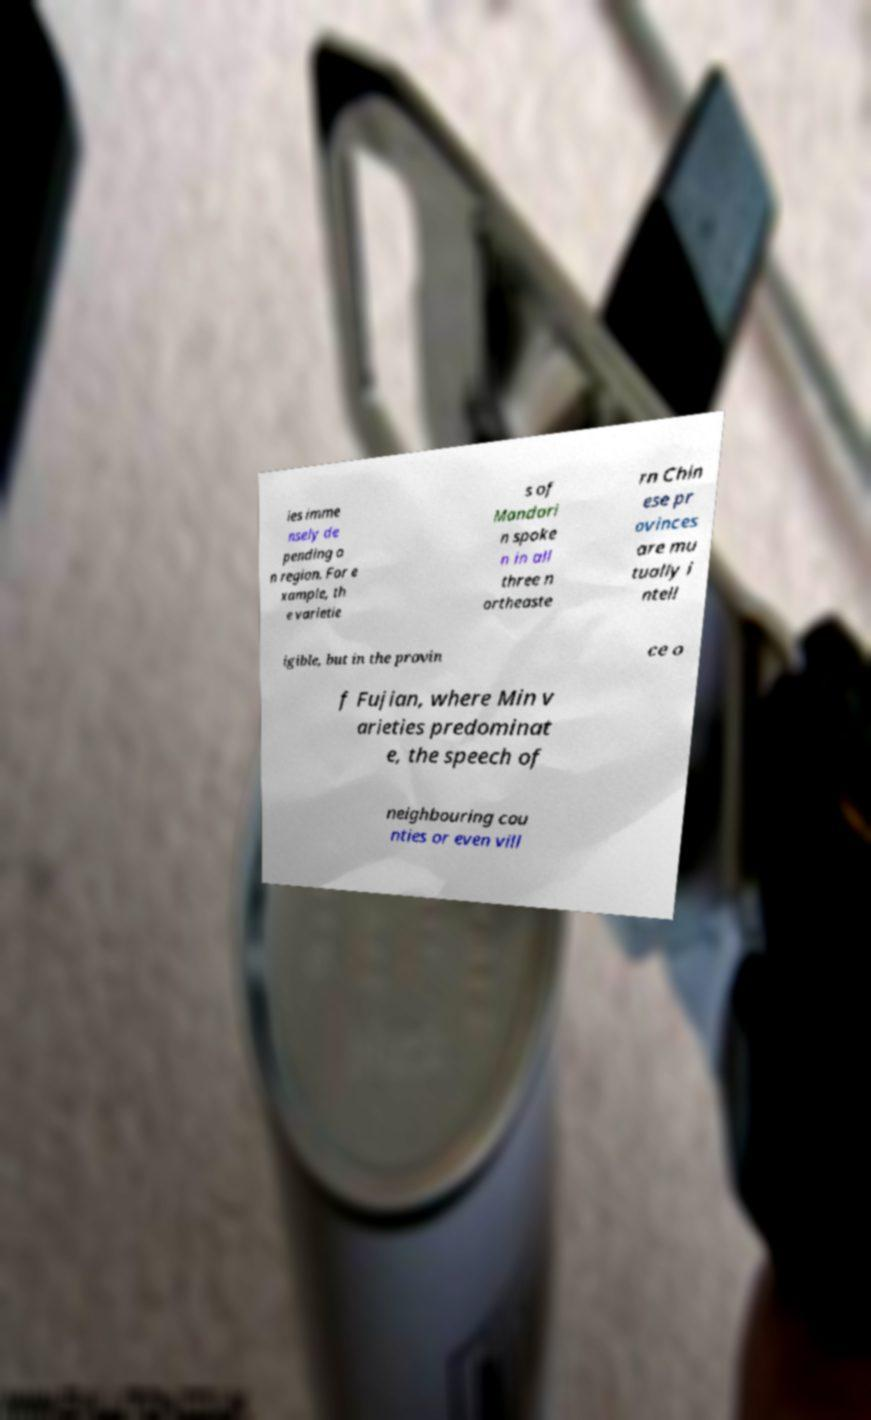Please read and relay the text visible in this image. What does it say? ies imme nsely de pending o n region. For e xample, th e varietie s of Mandari n spoke n in all three n ortheaste rn Chin ese pr ovinces are mu tually i ntell igible, but in the provin ce o f Fujian, where Min v arieties predominat e, the speech of neighbouring cou nties or even vill 